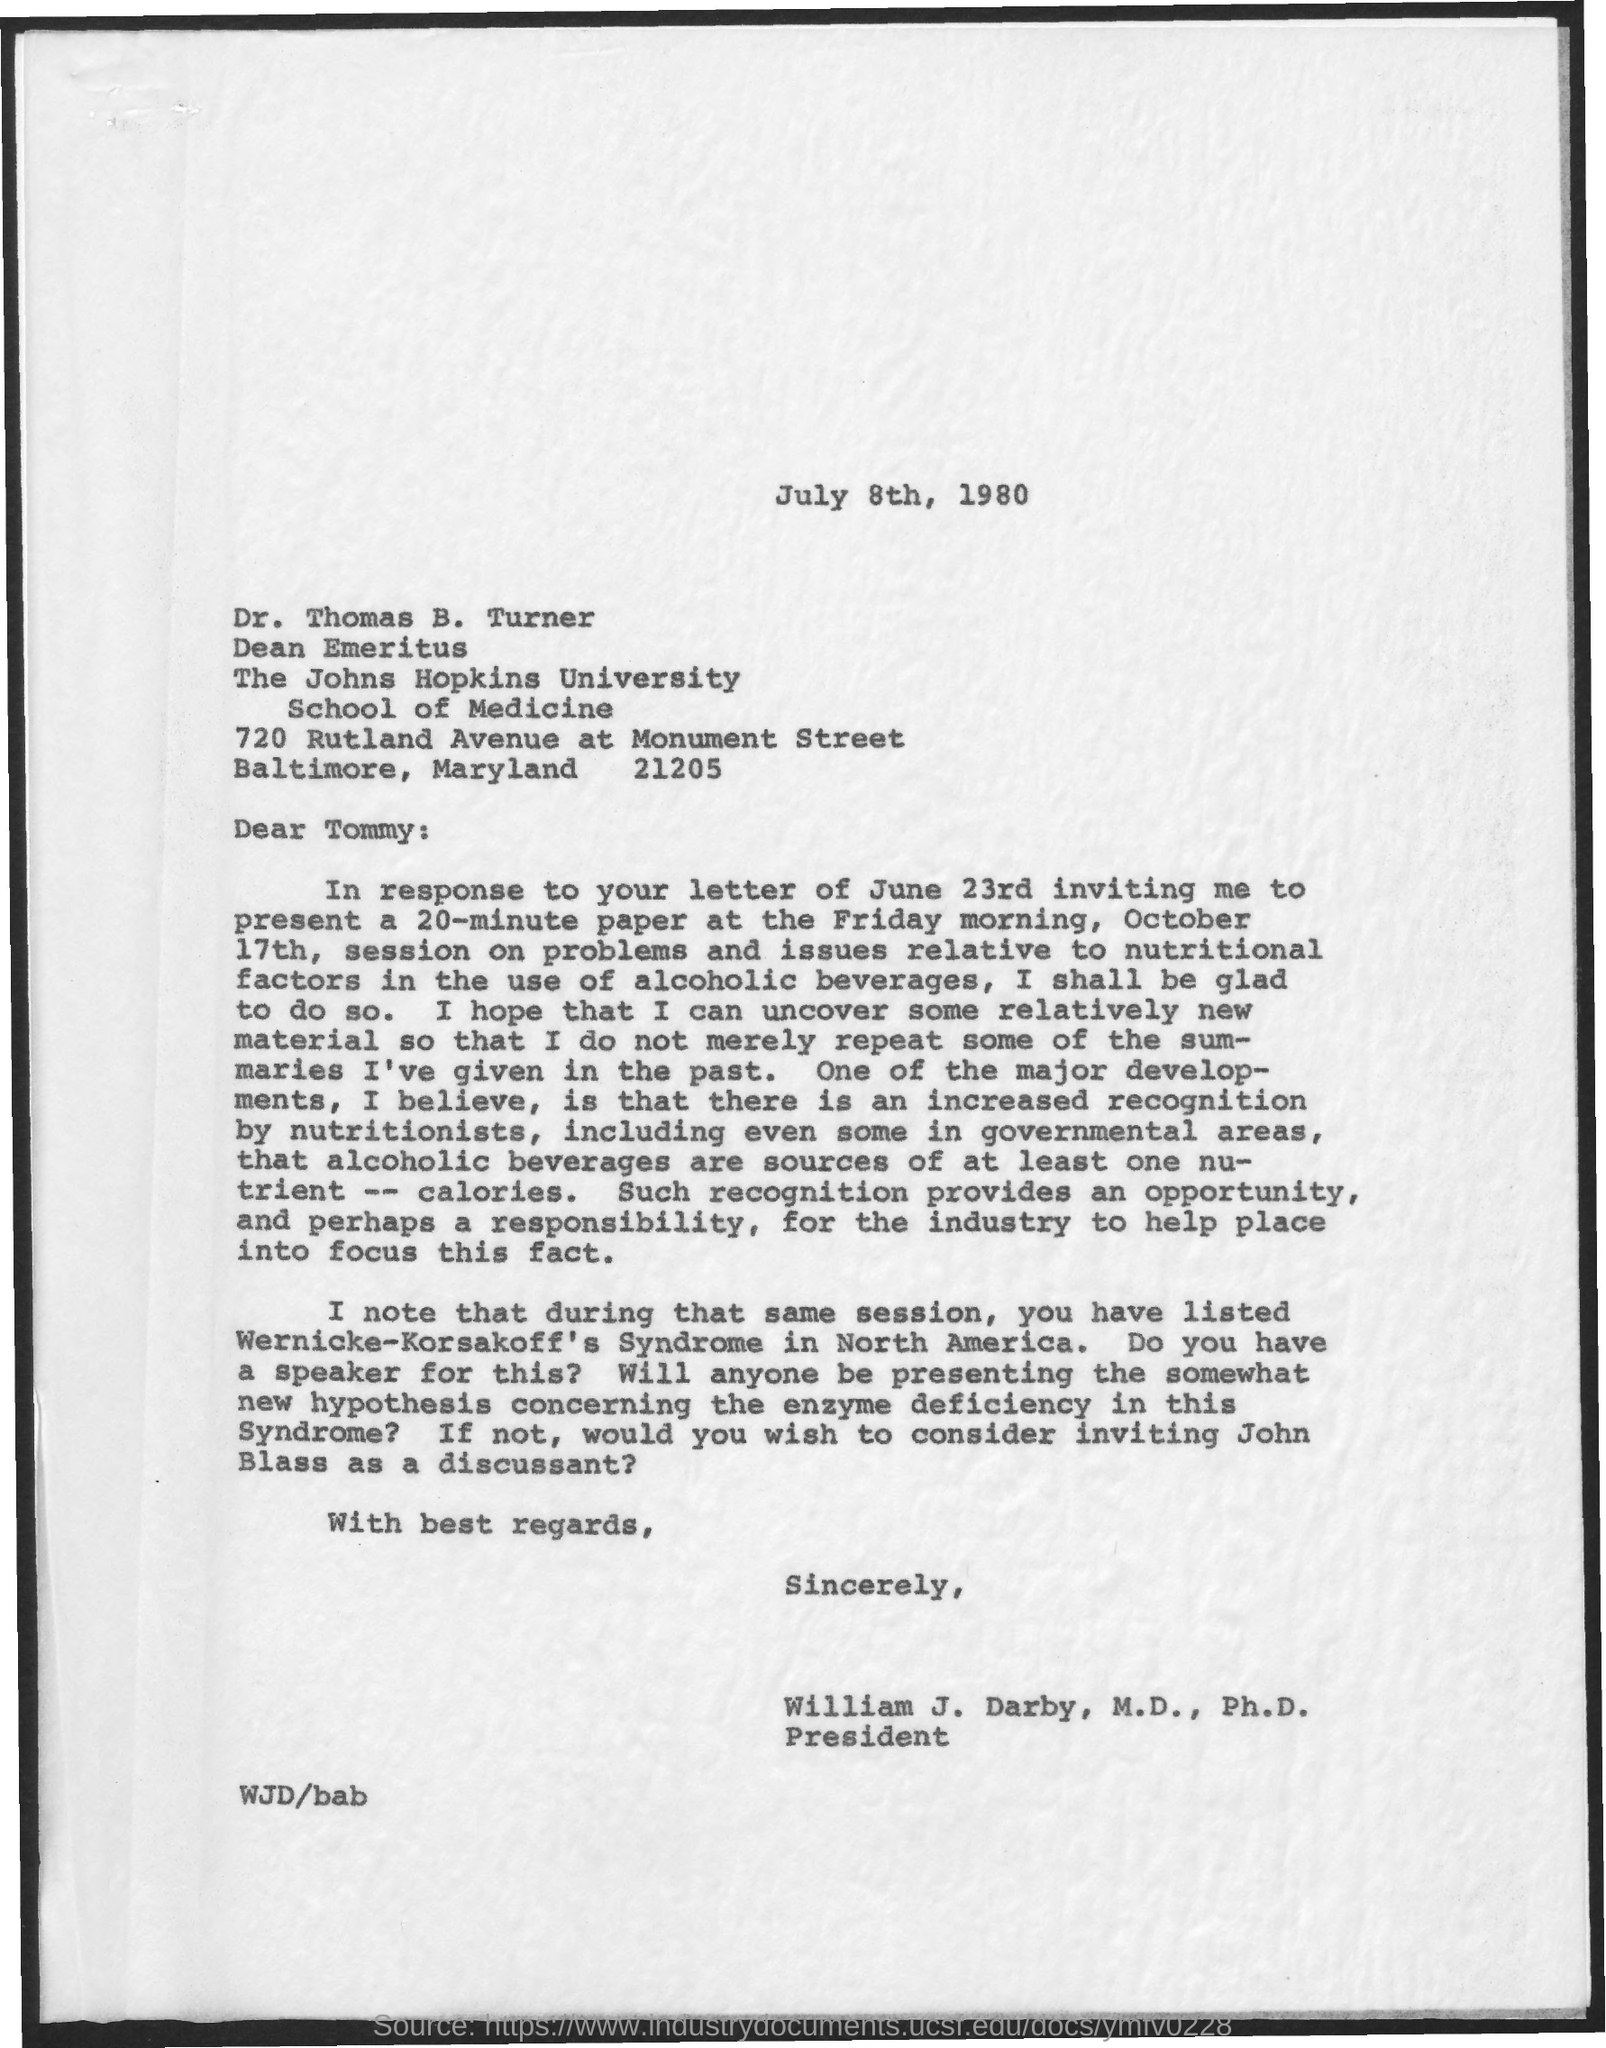Give some essential details in this illustration. The letter is addressed to Dr. Thomas B. Turner. During the same session, the topic of Wernicke-Korsakoff's Syndrome was listed in North America. 